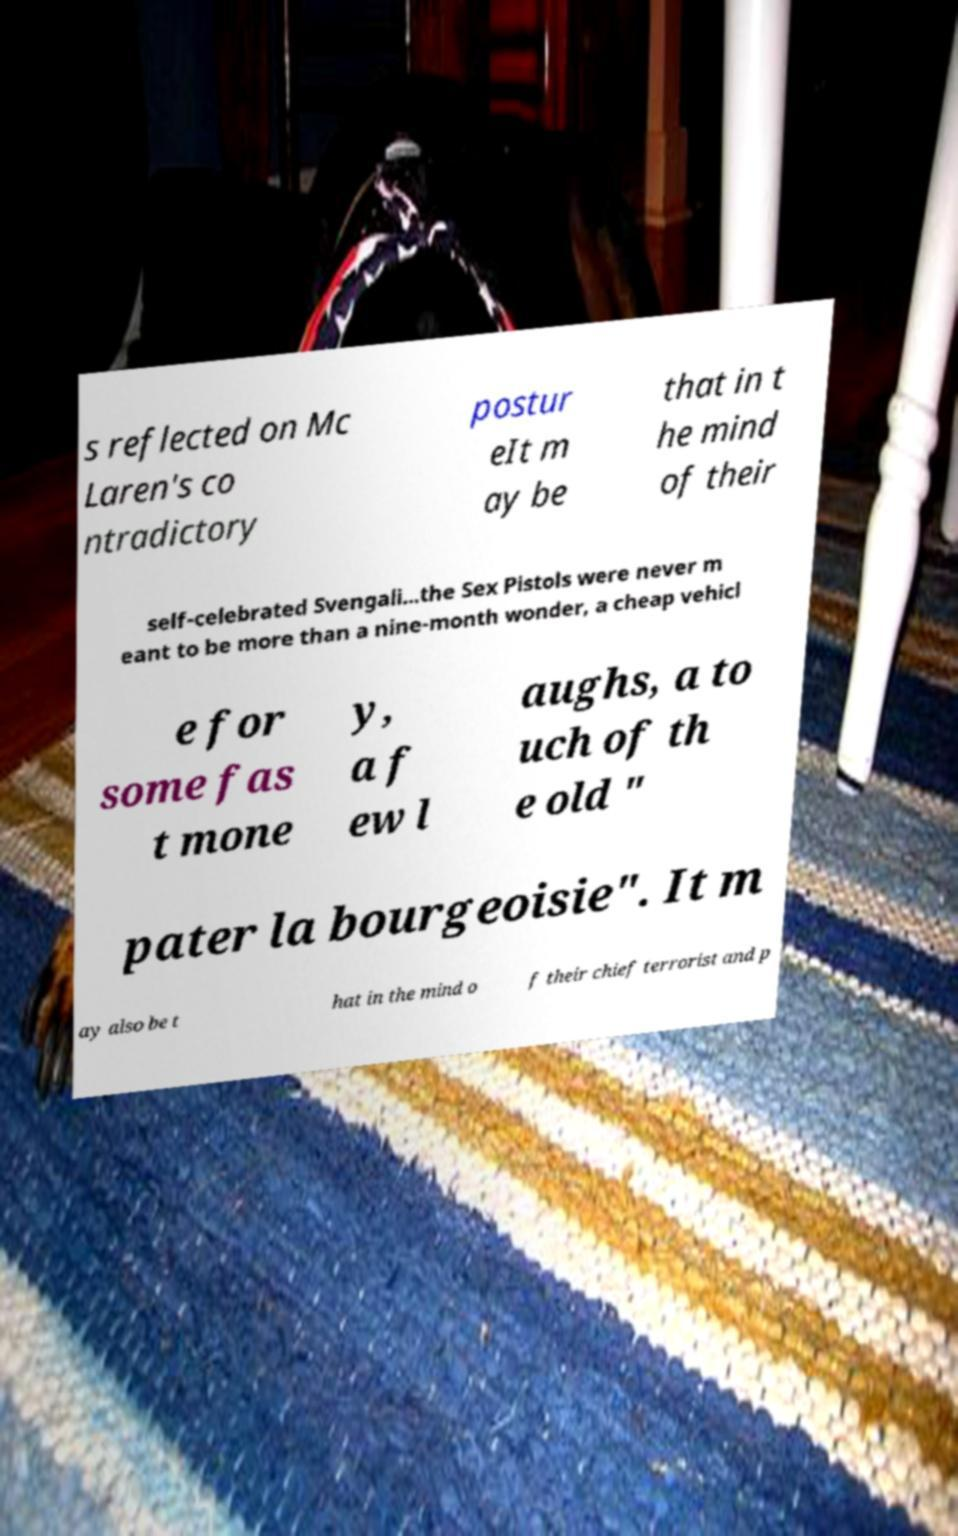Can you accurately transcribe the text from the provided image for me? s reflected on Mc Laren's co ntradictory postur eIt m ay be that in t he mind of their self-celebrated Svengali...the Sex Pistols were never m eant to be more than a nine-month wonder, a cheap vehicl e for some fas t mone y, a f ew l aughs, a to uch of th e old " pater la bourgeoisie". It m ay also be t hat in the mind o f their chief terrorist and p 